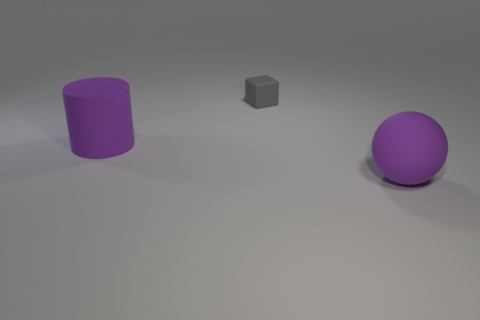What number of objects are either purple matte objects or cyan metallic spheres?
Offer a very short reply. 2. There is a big thing that is to the right of the matte cylinder; is there a purple rubber object that is on the left side of it?
Offer a very short reply. Yes. Is the number of large purple rubber things that are behind the cylinder greater than the number of large purple rubber cylinders to the left of the large purple rubber sphere?
Provide a short and direct response. No. There is a object that is the same color as the cylinder; what is its material?
Keep it short and to the point. Rubber. What number of other tiny blocks are the same color as the tiny block?
Make the answer very short. 0. Is the color of the big cylinder that is behind the big rubber sphere the same as the object that is on the right side of the tiny rubber block?
Provide a short and direct response. Yes. Are there any big purple cylinders to the left of the small matte thing?
Provide a short and direct response. Yes. What is the material of the purple ball?
Keep it short and to the point. Rubber. What shape is the purple thing right of the large purple cylinder?
Offer a terse response. Sphere. What is the size of the cylinder that is the same color as the big ball?
Your answer should be compact. Large. 